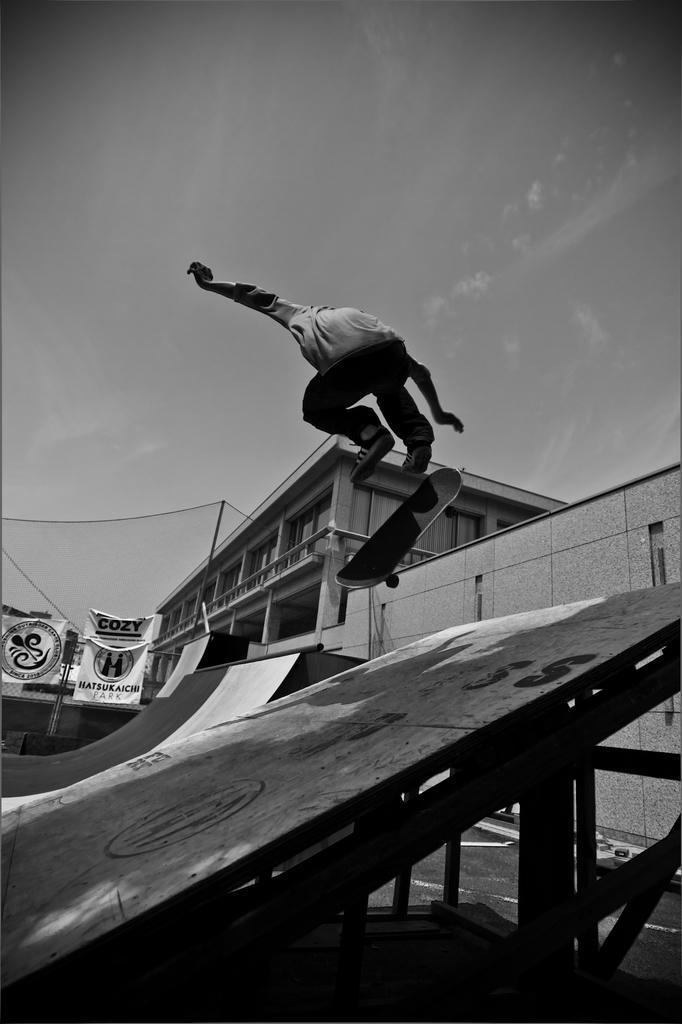In one or two sentences, can you explain what this image depicts? In this picture we can see a person skating on a skateboard, in the background there are banners, we can see a building on the right side, there is the sky at the top of the picture, it is a black and white picture. 